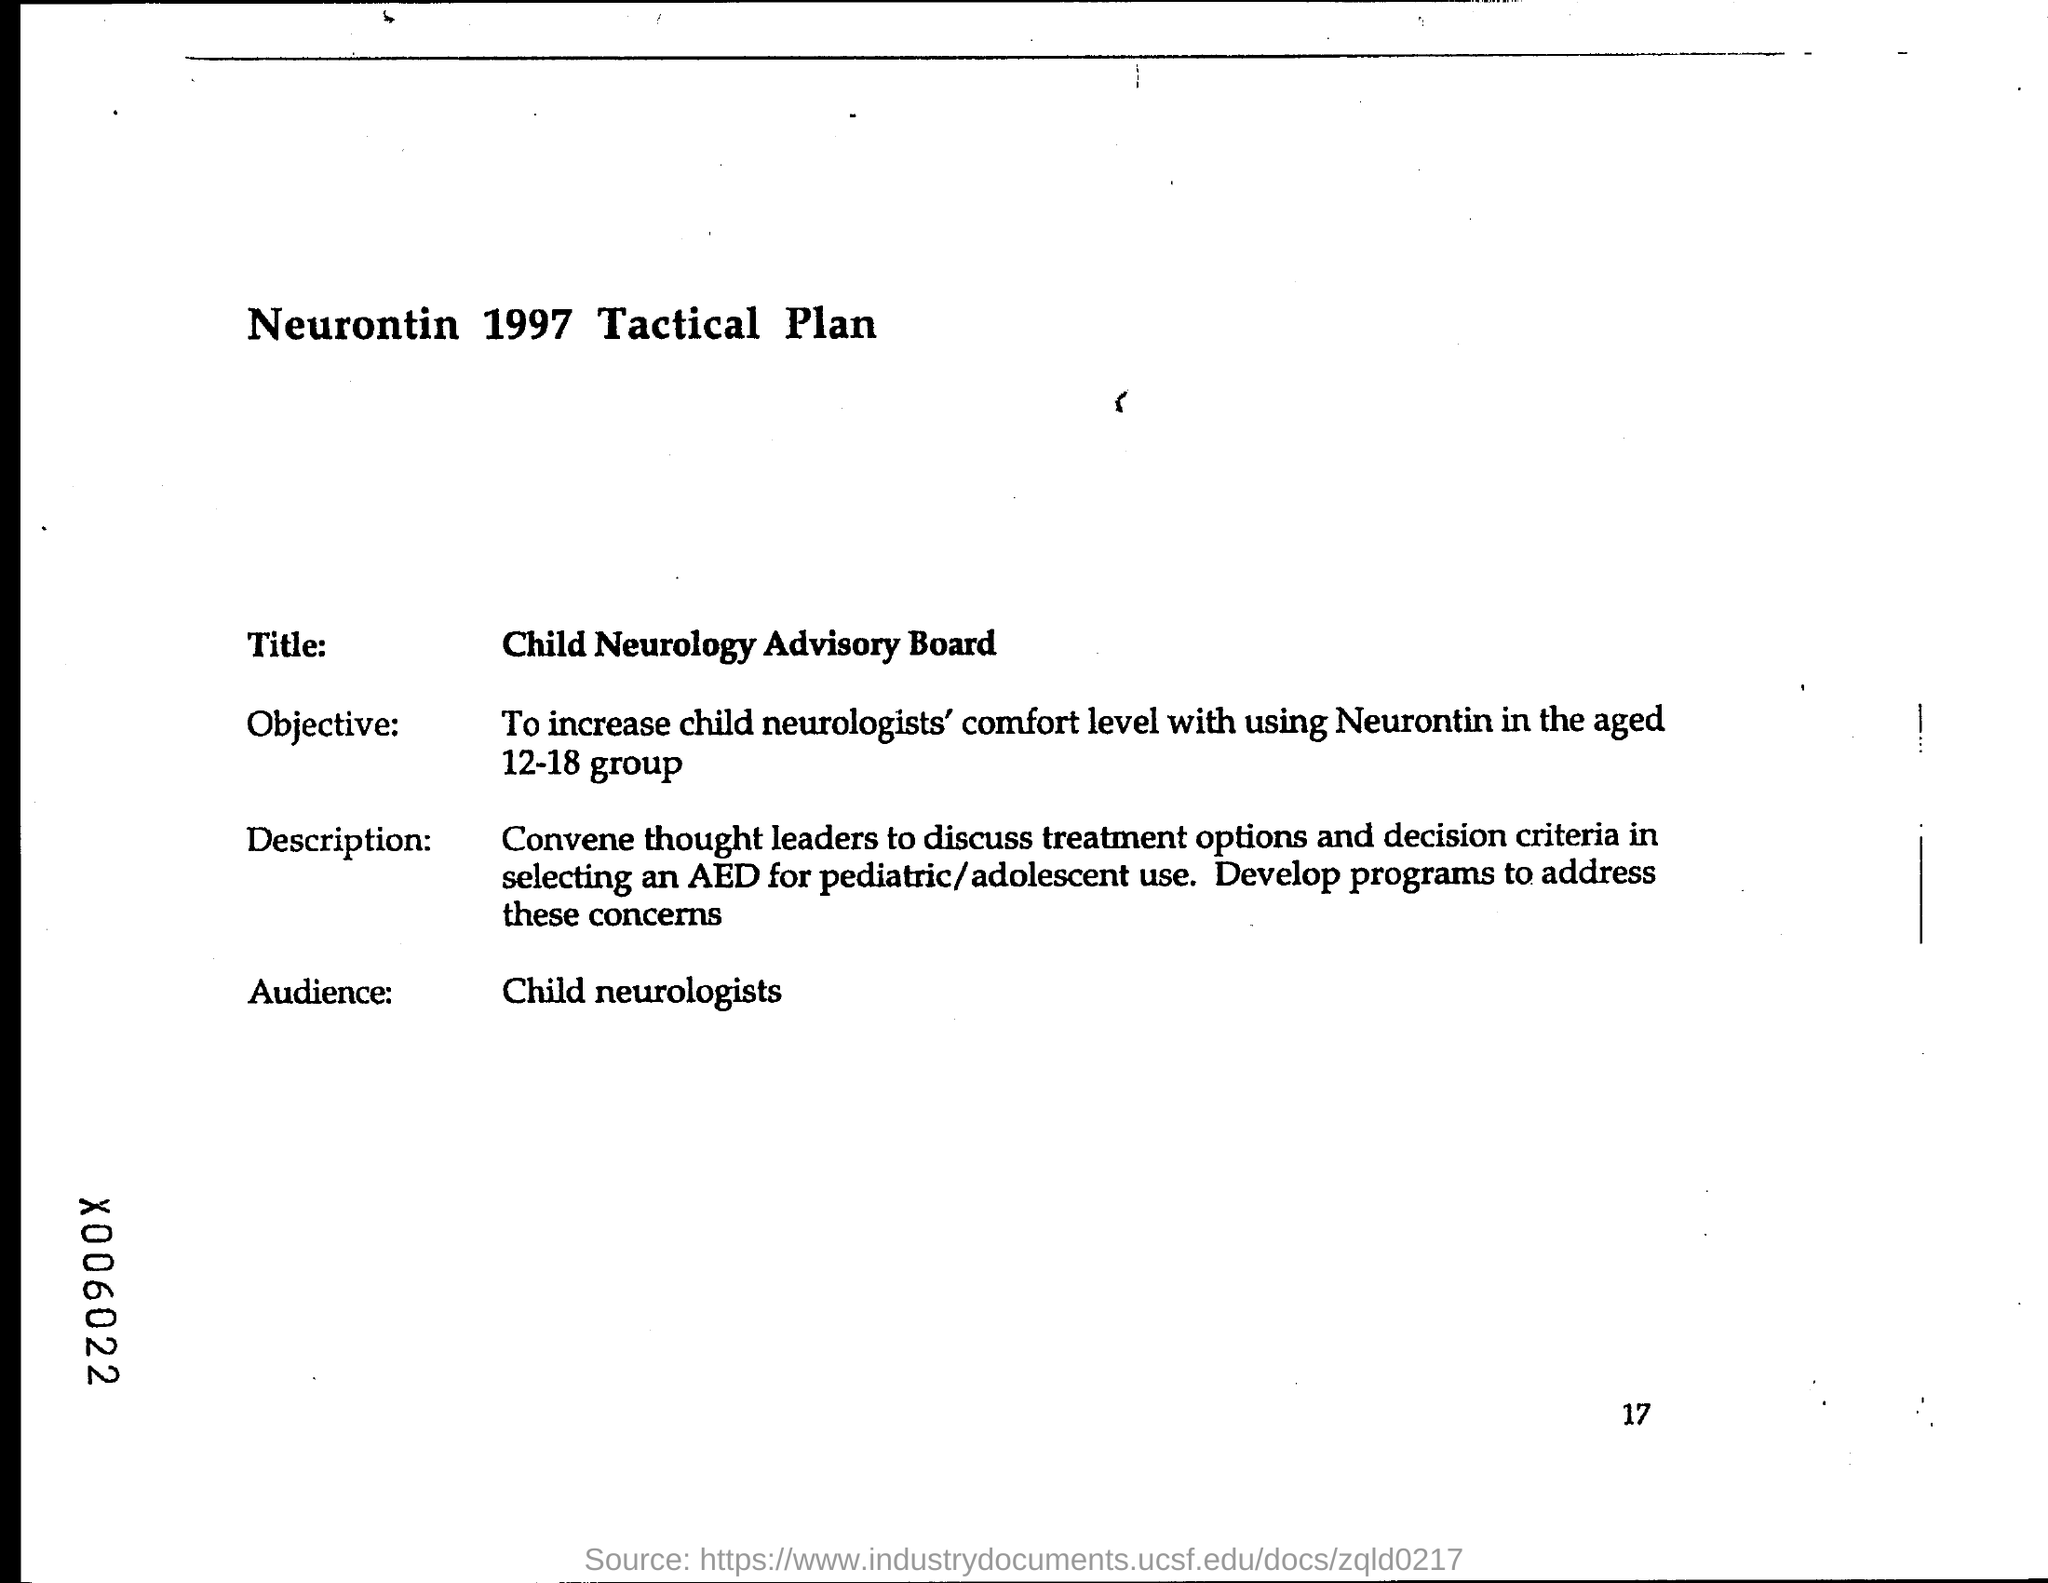Specify some key components in this picture. The intended audience for this text is child neurologists. The title is "Child Neurology Advisory Board. The objective is to enhance the confidence of child neurologists in prescribing Neurontin to individuals within the age range of 12 to 18. The heading of the document mentions the year 1997. 